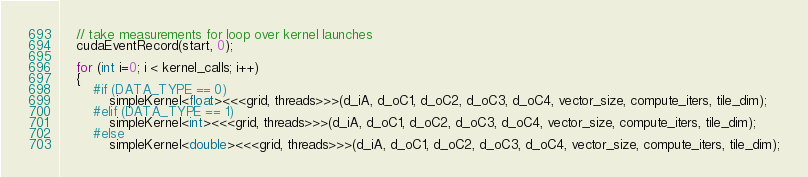<code> <loc_0><loc_0><loc_500><loc_500><_Cuda_>    // take measurements for loop over kernel launches
    cudaEventRecord(start, 0);

    for (int i=0; i < kernel_calls; i++)
    {
        #if (DATA_TYPE == 0)
            simpleKernel<float><<<grid, threads>>>(d_iA, d_oC1, d_oC2, d_oC3, d_oC4, vector_size, compute_iters, tile_dim);
        #elif (DATA_TYPE == 1)
            simpleKernel<int><<<grid, threads>>>(d_iA, d_oC1, d_oC2, d_oC3, d_oC4, vector_size, compute_iters, tile_dim);
        #else
            simpleKernel<double><<<grid, threads>>>(d_iA, d_oC1, d_oC2, d_oC3, d_oC4, vector_size, compute_iters, tile_dim);</code> 